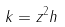Convert formula to latex. <formula><loc_0><loc_0><loc_500><loc_500>k = z ^ { 2 } h</formula> 